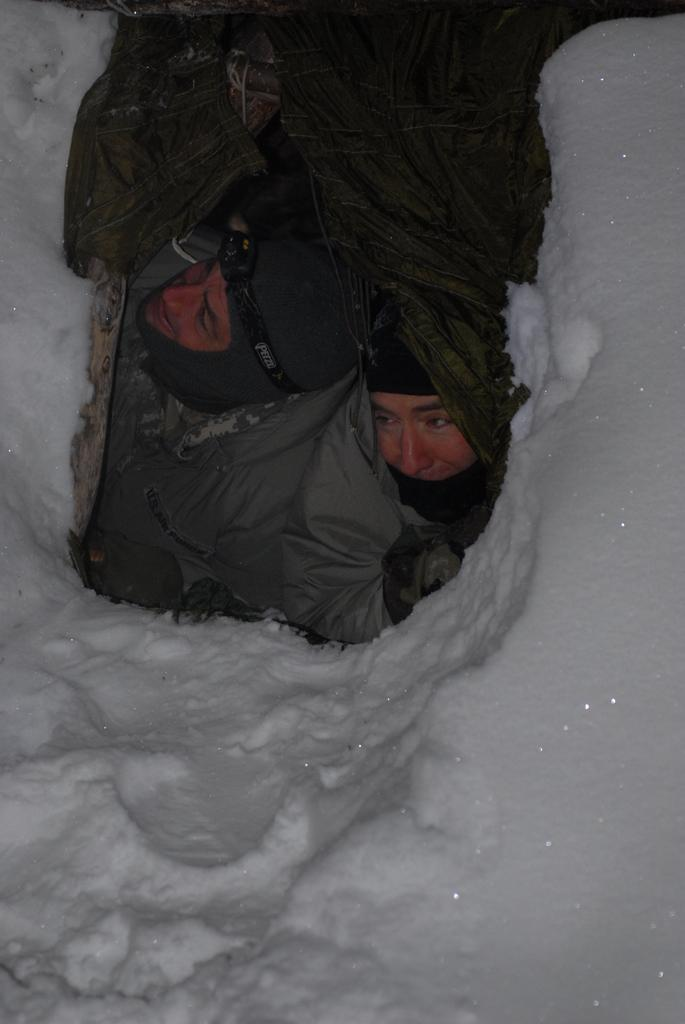How many people are in the image? There are two people in the image. Where are the people located in the image? The people are in the center of the image. What is the environment like in the image? The people are surrounded by snow. What type of robin can be seen flying in the image? There are no birds, including robins, present in the image. How many tin cans are visible in the image? There are no tin cans visible in the image. 